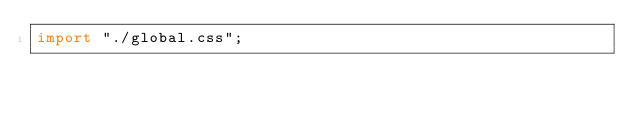Convert code to text. <code><loc_0><loc_0><loc_500><loc_500><_JavaScript_>import "./global.css";
</code> 